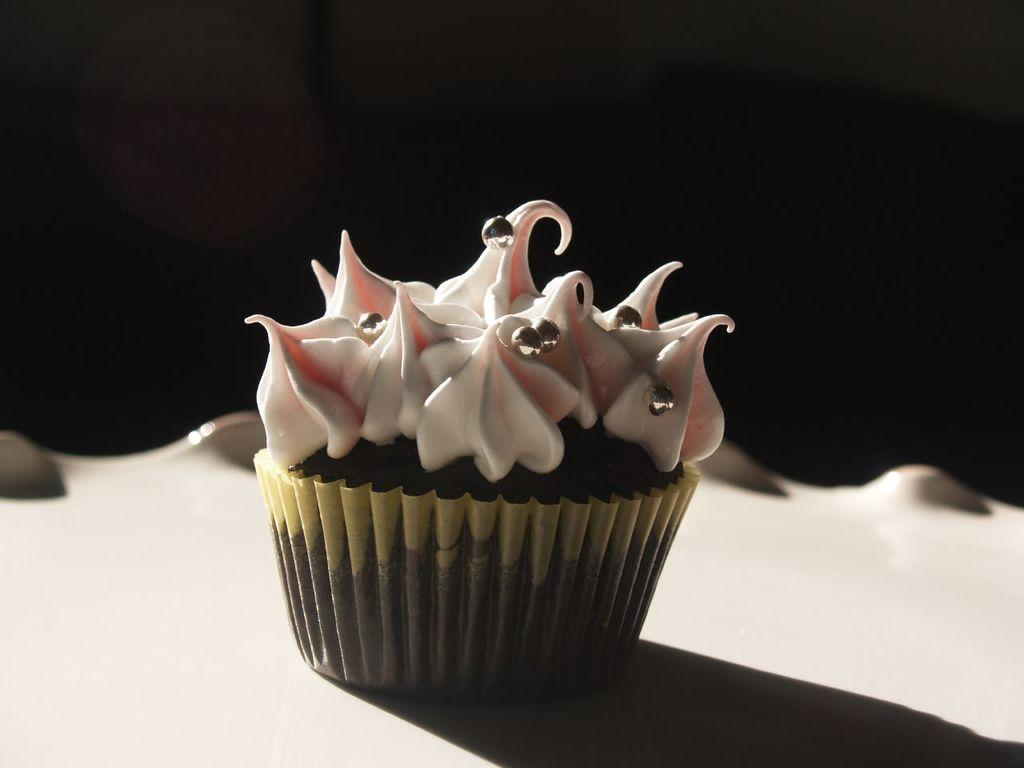What type of food is visible in the image? There is a cupcake in the image. What is the cupcake resting on? The cupcake is on an object. Can you describe the background of the image? The background of the image is dark. What type of harmony is being played in the background of the image? There is no music or harmony present in the image; it only features a cupcake on an object with a dark background. 